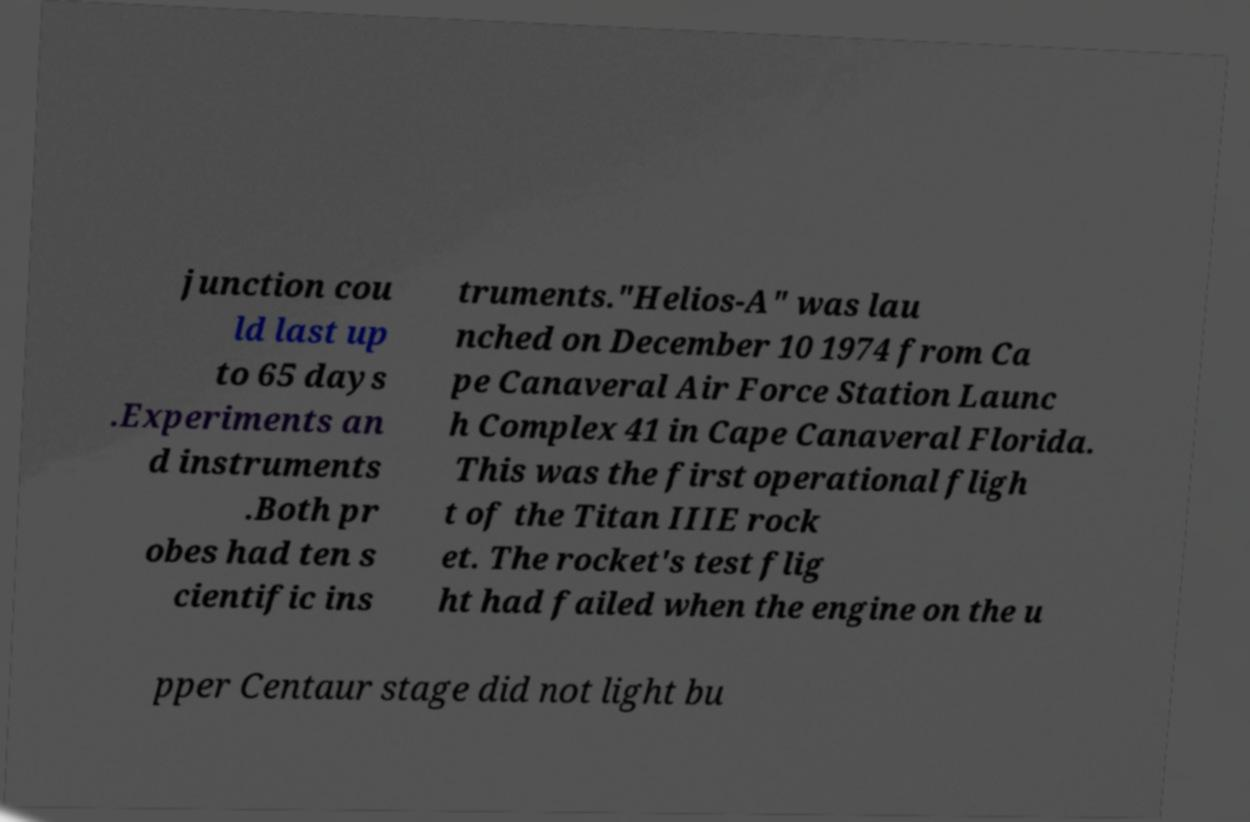Please identify and transcribe the text found in this image. junction cou ld last up to 65 days .Experiments an d instruments .Both pr obes had ten s cientific ins truments."Helios-A" was lau nched on December 10 1974 from Ca pe Canaveral Air Force Station Launc h Complex 41 in Cape Canaveral Florida. This was the first operational fligh t of the Titan IIIE rock et. The rocket's test flig ht had failed when the engine on the u pper Centaur stage did not light bu 